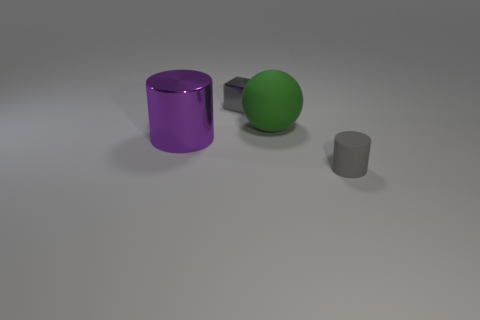Add 3 big things. How many objects exist? 7 Subtract all blocks. How many objects are left? 3 Subtract 0 cyan cubes. How many objects are left? 4 Subtract all small purple matte cylinders. Subtract all big green matte spheres. How many objects are left? 3 Add 3 metal cylinders. How many metal cylinders are left? 4 Add 3 big matte balls. How many big matte balls exist? 4 